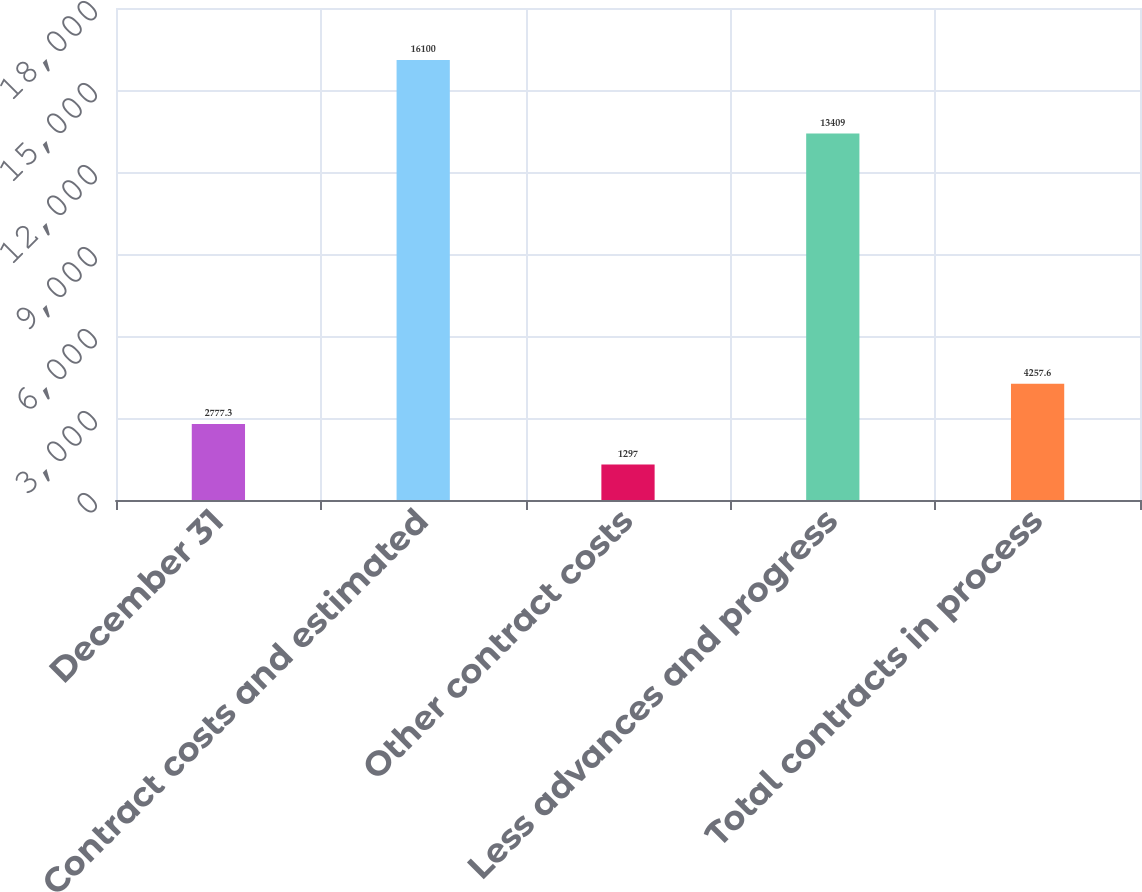Convert chart to OTSL. <chart><loc_0><loc_0><loc_500><loc_500><bar_chart><fcel>December 31<fcel>Contract costs and estimated<fcel>Other contract costs<fcel>Less advances and progress<fcel>Total contracts in process<nl><fcel>2777.3<fcel>16100<fcel>1297<fcel>13409<fcel>4257.6<nl></chart> 